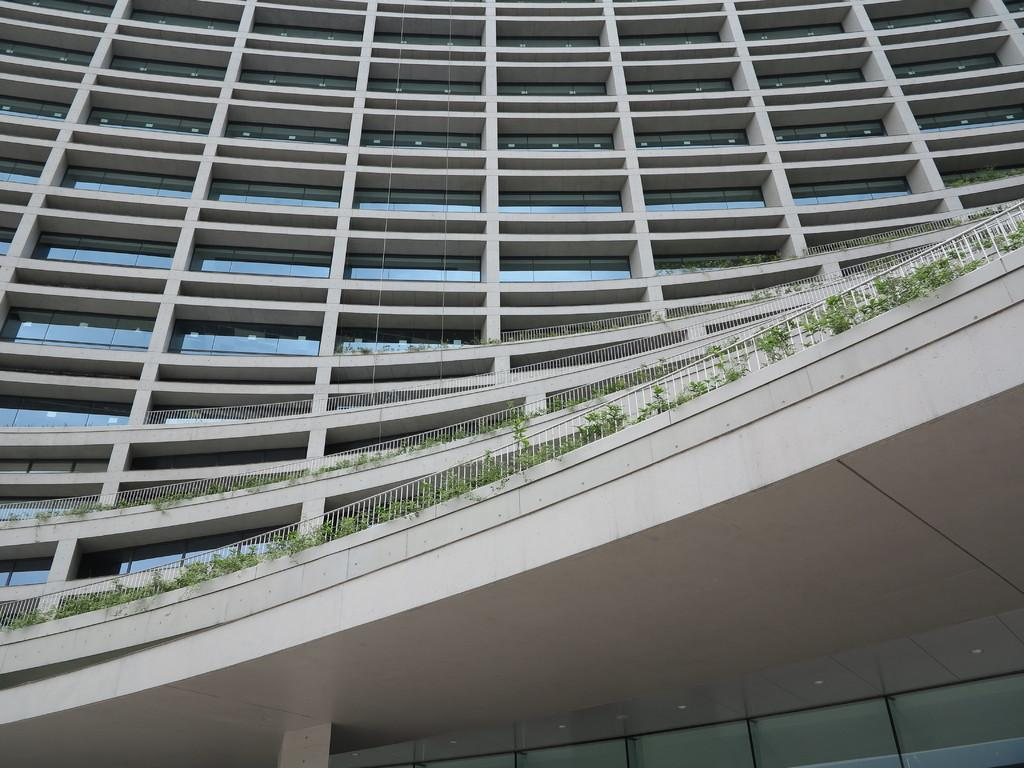What type of structure is present in the image? There is a building in the image. What type of vegetation can be seen in the image? There are a few plants in the image. What type of pin can be seen holding the building in place in the image? There is no pin present in the image, and the building is not being held in place by any such object. What type of pan is being used to cook the plants in the image? There is no pan present in the image, and the plants are not being cooked. 